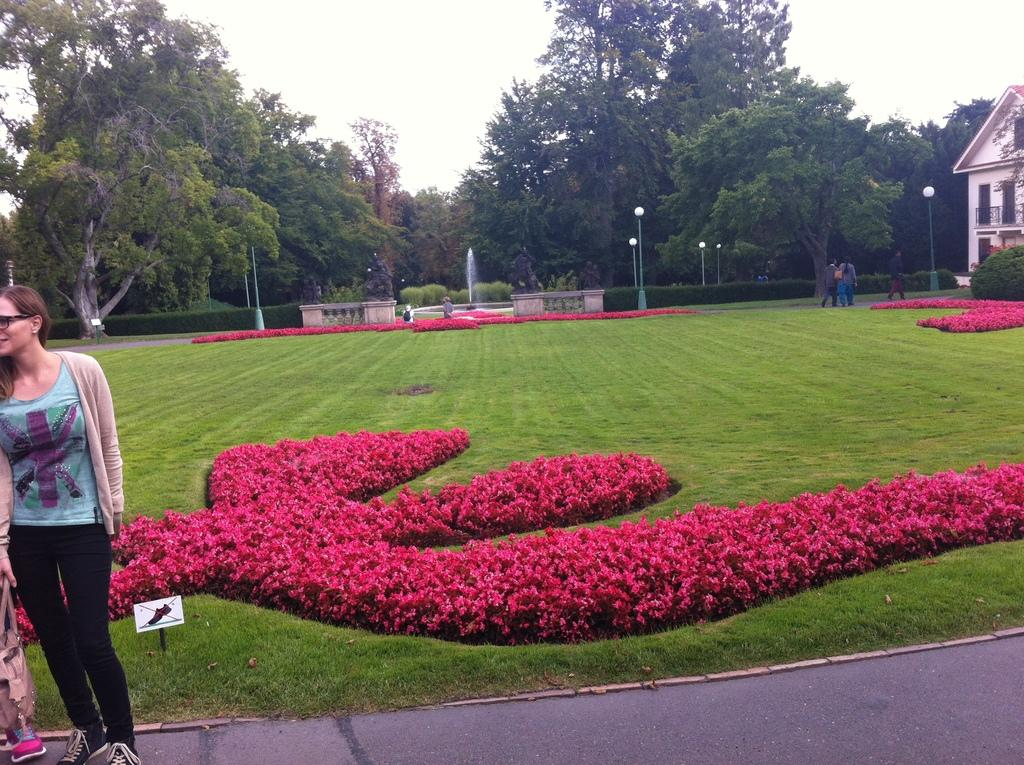How many people can be seen in the image? There are people in the image, but the exact number is not specified. What type of pathway is visible in the image? There is a road in the image. What is the natural environment like in the image? The ground with grass is visible in the image, and there are trees present as well. What type of decorative elements are present in the image? Flowers and a fountain are present in the image. What type of structure is visible in the image? There is a building in the image. What is visible in the sky in the image? The sky is visible in the image. What type of box can be seen falling from the sky in the image? There is no box falling from the sky in the image. How many people have died in the image? There is no indication of death or any dangerous situation in the image. 